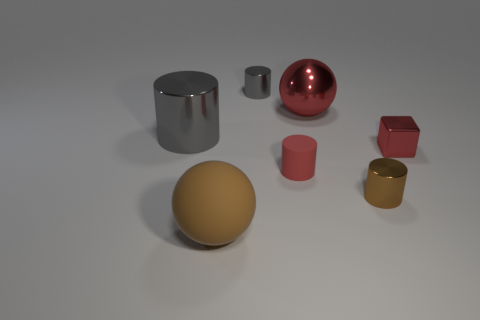Subtract all red spheres. How many spheres are left? 1 Subtract all shiny cylinders. How many cylinders are left? 1 Subtract 0 yellow cubes. How many objects are left? 7 Subtract all spheres. How many objects are left? 5 Subtract 1 cubes. How many cubes are left? 0 Subtract all purple cylinders. Subtract all green spheres. How many cylinders are left? 4 Subtract all blue blocks. How many purple spheres are left? 0 Subtract all big red rubber blocks. Subtract all gray metallic cylinders. How many objects are left? 5 Add 3 small red rubber cylinders. How many small red rubber cylinders are left? 4 Add 2 big brown matte objects. How many big brown matte objects exist? 3 